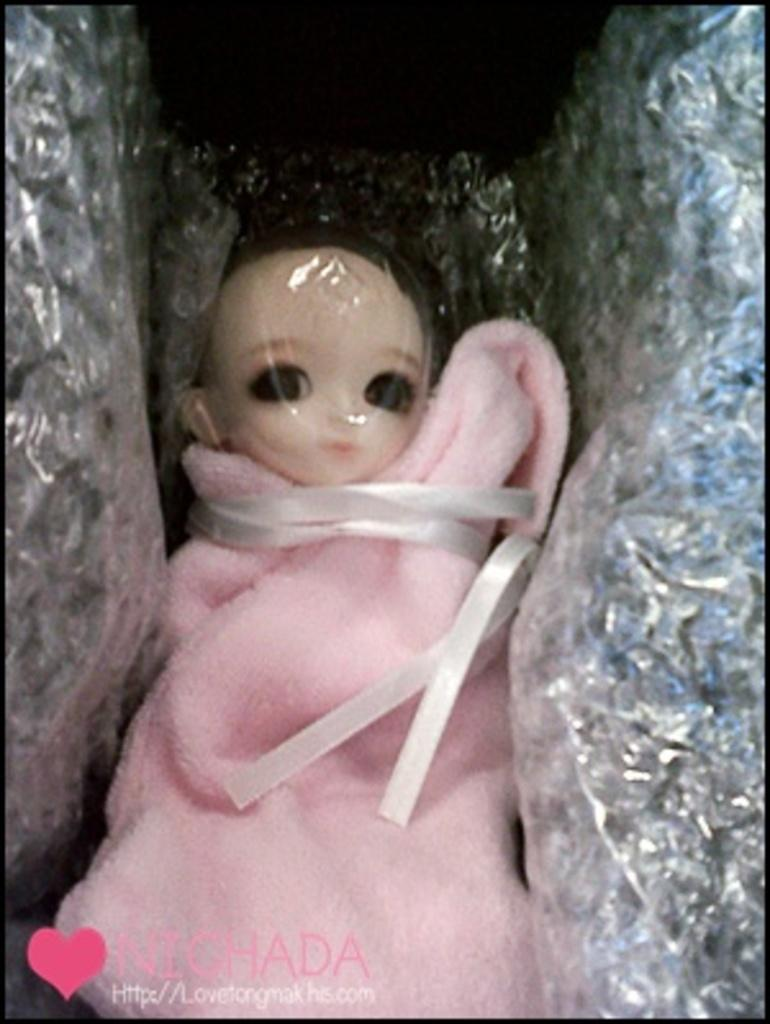What is the main subject in the image? There is a doll in the image. How is the doll dressed or wrapped? The doll is wrapped with pink cloth. Does the doll have any additional covering? Yes, the doll has a cover. What type of party is happening in the image? There is no party depicted in the image; it only shows a doll wrapped with pink cloth and covered. Can you see a bat flying in the image? There is no bat present in the image. 